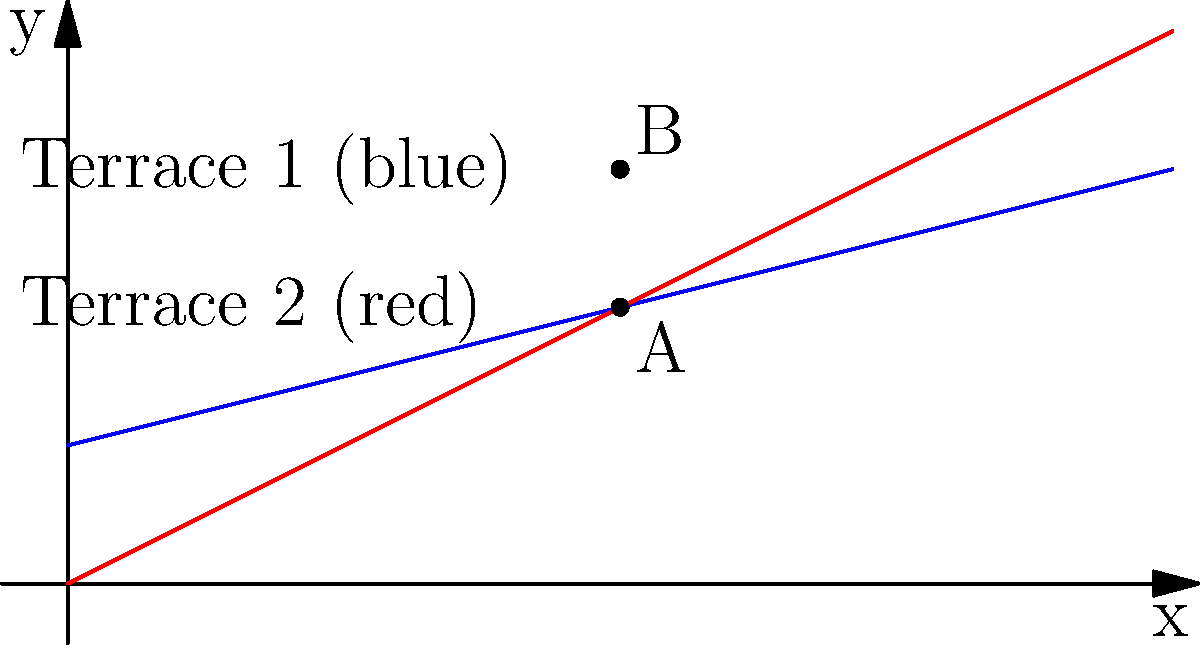As a successful farmer utilizing modern agricultural techniques, you've implemented terraced farming on your sloped land. The graph shows two terrace levels represented by linear equations. Terrace 1 (blue) has the equation $y = 0.25x + 1$, and Terrace 2 (red) has the equation $y = 0.5x$. Calculate the vertical distance between points A and B at $x = 4$ on these terraces. How does this distance relate to water flow and erosion control in your terraced system? To solve this problem, we'll follow these steps:

1) First, let's find the y-coordinates of points A and B at x = 4:

   For Terrace 1 (point B): 
   $y = 0.25x + 1$
   $y = 0.25(4) + 1 = 1 + 1 = 2$

   For Terrace 2 (point A):
   $y = 0.5x$
   $y = 0.5(4) = 2$

2) The vertical distance is the difference between these y-coordinates:

   Vertical distance = $y_B - y_A = 3 - 2 = 1$

3) Interpretation for terraced farming:

   This vertical distance of 1 unit represents the height difference between the two terraces at x = 4. In terraced farming, this height difference is crucial for:

   a) Water flow control: The vertical drop allows water to flow from one terrace to another in a controlled manner, preventing rapid runoff.
   
   b) Erosion prevention: By breaking the slope into smaller segments, the terraces reduce the velocity of water flow, minimizing soil erosion.
   
   c) Moisture retention: Each terrace acts as a small catchment area, allowing more time for water to infiltrate the soil.

4) The different slopes (0.25 for Terrace 1 and 0.5 for Terrace 2) indicate varying gradients in the farmland. This variation can be beneficial for:

   a) Diverse crop cultivation: Different slopes can create microclimates suitable for various crops.
   
   b) Optimized sun exposure: Varying slopes can help optimize sunlight distribution across the farm.

5) As a successful farmer using modern techniques, understanding these gradients and vertical distances helps in:

   a) Proper terrace design and maintenance
   b) Efficient irrigation system planning
   c) Crop selection and rotation strategies
   d) Overall farm layout optimization
Answer: 1 unit; controls water flow and prevents erosion 